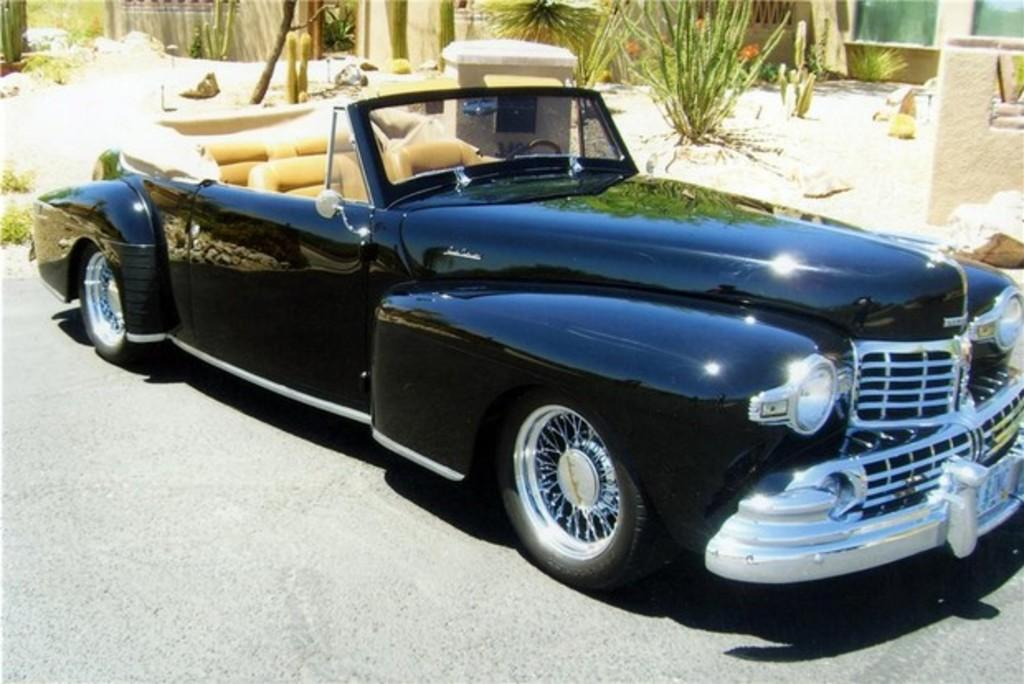What is the main subject of the image? There is a black color car in the center of the image. What is located at the bottom of the image? There is a road at the bottom of the image. What can be seen in the background of the image? There are plants in the background of the image. What type of bird can be seen perched on the car in the image? There is no bird present on the car in the image. Can you tell me how many apples are on the ground near the car? There are no apples visible in the image; it only features a black color car, a road, and plants in the background. 